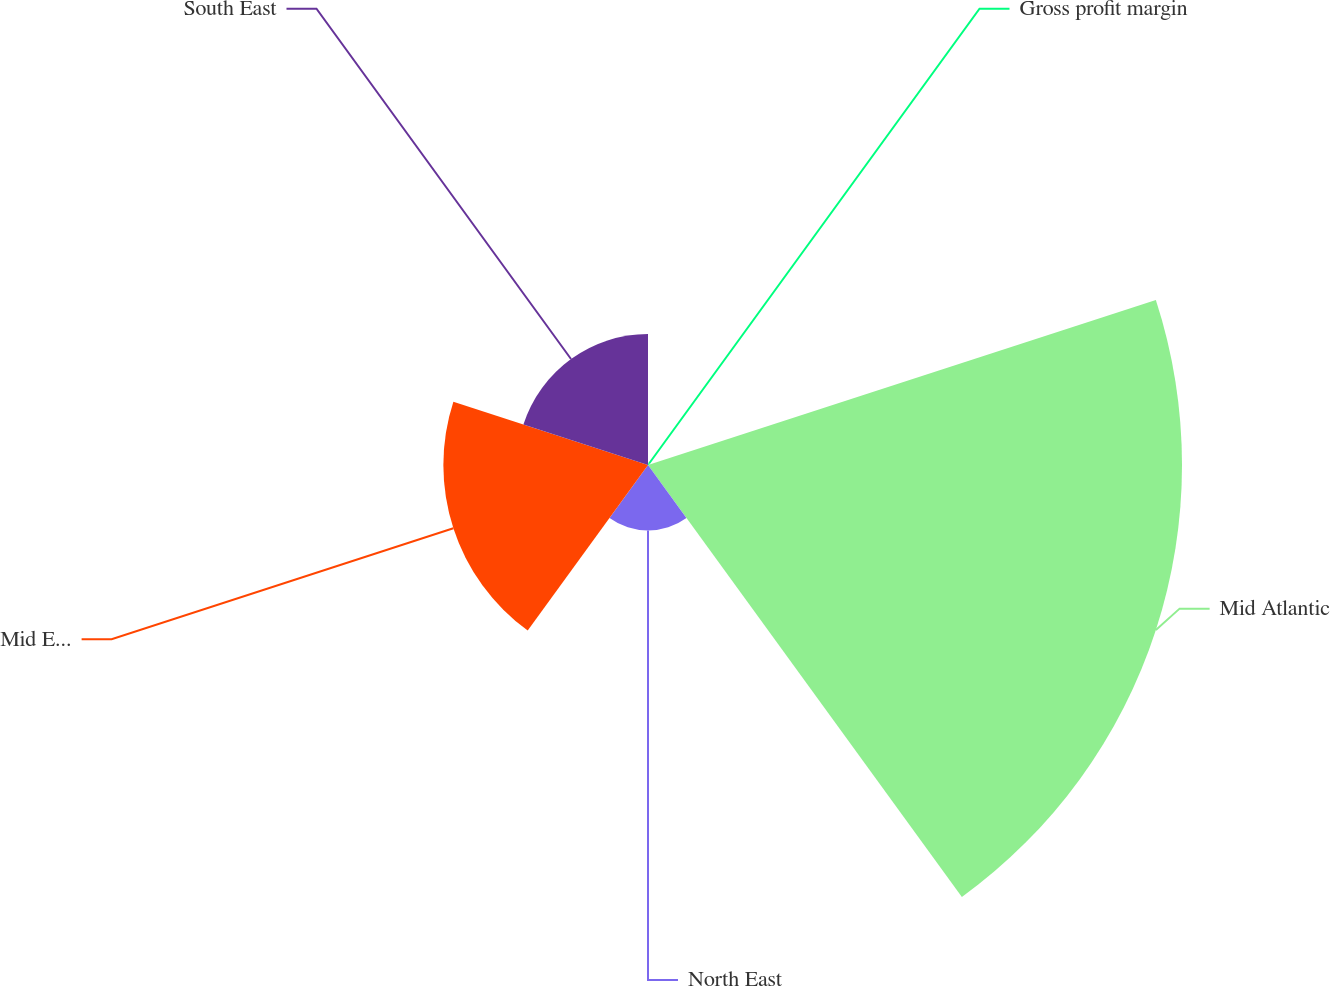Convert chart. <chart><loc_0><loc_0><loc_500><loc_500><pie_chart><fcel>Gross profit margin<fcel>Mid Atlantic<fcel>North East<fcel>Mid East<fcel>South East<nl><fcel>0.2%<fcel>56.99%<fcel>6.98%<fcel>21.84%<fcel>13.98%<nl></chart> 